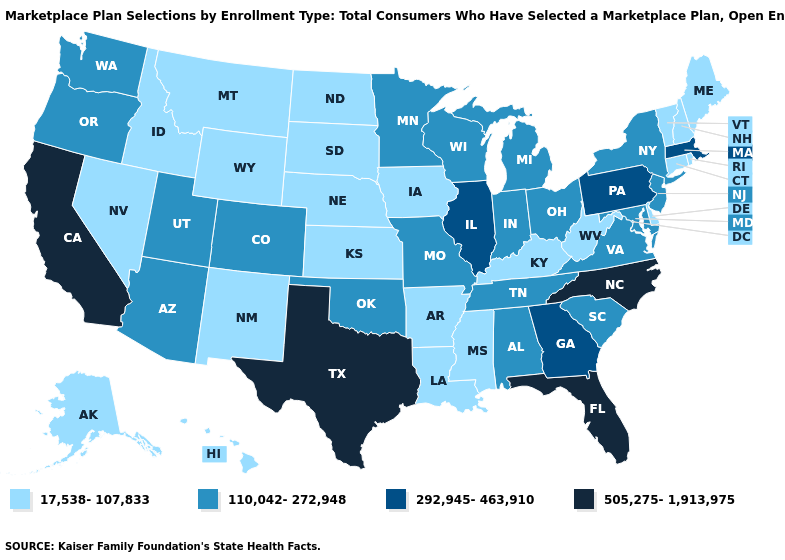What is the value of North Carolina?
Quick response, please. 505,275-1,913,975. What is the value of Arizona?
Give a very brief answer. 110,042-272,948. What is the highest value in the MidWest ?
Concise answer only. 292,945-463,910. Does Connecticut have a lower value than Idaho?
Short answer required. No. Which states have the lowest value in the USA?
Give a very brief answer. Alaska, Arkansas, Connecticut, Delaware, Hawaii, Idaho, Iowa, Kansas, Kentucky, Louisiana, Maine, Mississippi, Montana, Nebraska, Nevada, New Hampshire, New Mexico, North Dakota, Rhode Island, South Dakota, Vermont, West Virginia, Wyoming. What is the value of Arizona?
Write a very short answer. 110,042-272,948. Name the states that have a value in the range 505,275-1,913,975?
Short answer required. California, Florida, North Carolina, Texas. Which states hav the highest value in the MidWest?
Answer briefly. Illinois. Name the states that have a value in the range 17,538-107,833?
Give a very brief answer. Alaska, Arkansas, Connecticut, Delaware, Hawaii, Idaho, Iowa, Kansas, Kentucky, Louisiana, Maine, Mississippi, Montana, Nebraska, Nevada, New Hampshire, New Mexico, North Dakota, Rhode Island, South Dakota, Vermont, West Virginia, Wyoming. Name the states that have a value in the range 17,538-107,833?
Keep it brief. Alaska, Arkansas, Connecticut, Delaware, Hawaii, Idaho, Iowa, Kansas, Kentucky, Louisiana, Maine, Mississippi, Montana, Nebraska, Nevada, New Hampshire, New Mexico, North Dakota, Rhode Island, South Dakota, Vermont, West Virginia, Wyoming. Which states have the lowest value in the South?
Answer briefly. Arkansas, Delaware, Kentucky, Louisiana, Mississippi, West Virginia. Does Illinois have the lowest value in the USA?
Write a very short answer. No. What is the value of Alaska?
Answer briefly. 17,538-107,833. Among the states that border North Dakota , does Minnesota have the lowest value?
Quick response, please. No. What is the lowest value in the Northeast?
Short answer required. 17,538-107,833. 